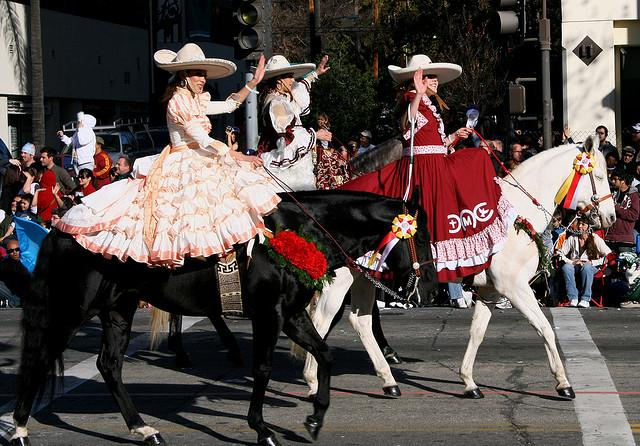What color is the woman's dress who is riding a white stallion? Please explain your reasoning. red. The color is red. 